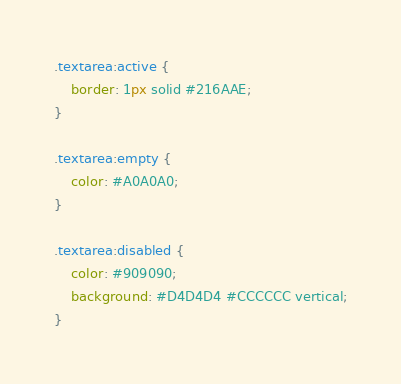<code> <loc_0><loc_0><loc_500><loc_500><_CSS_>.textarea:active {
    border: 1px solid #216AAE;
}

.textarea:empty {
    color: #A0A0A0;
}

.textarea:disabled {
    color: #909090;
    background: #D4D4D4 #CCCCCC vertical;
}</code> 